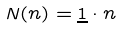Convert formula to latex. <formula><loc_0><loc_0><loc_500><loc_500>N ( { n } ) = { \underline { 1 } } \cdot { n }</formula> 